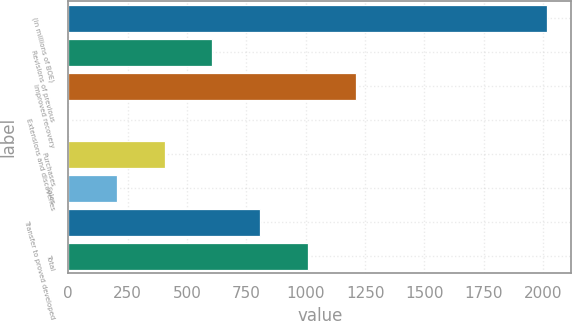Convert chart to OTSL. <chart><loc_0><loc_0><loc_500><loc_500><bar_chart><fcel>(in millions of BOE)<fcel>Revisions of previous<fcel>Improved recovery<fcel>Extensions and discoveries<fcel>Purchases<fcel>Sales<fcel>Transfer to proved developed<fcel>Total<nl><fcel>2017<fcel>607.2<fcel>1211.4<fcel>3<fcel>405.8<fcel>204.4<fcel>808.6<fcel>1010<nl></chart> 